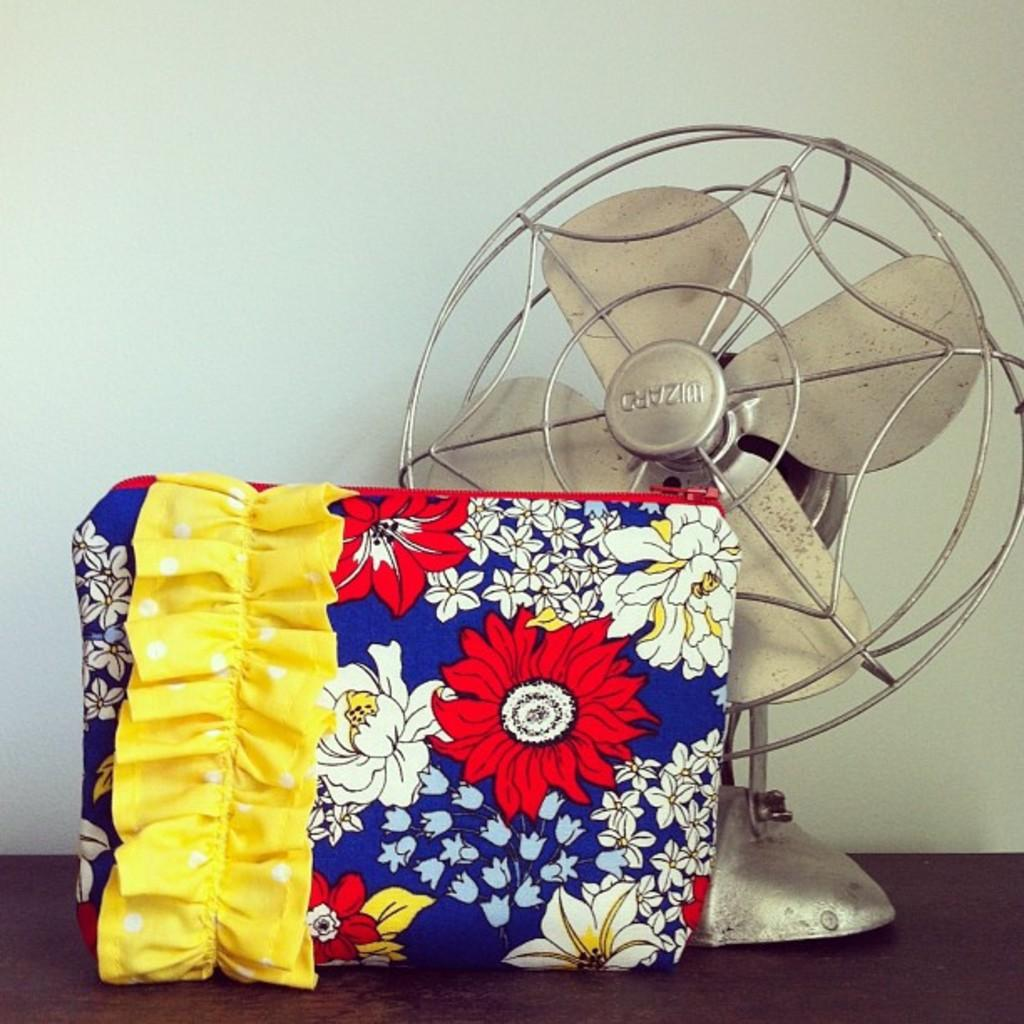What type of appliance is visible in the image? There is a table fan in the image. What else can be seen in the image besides the table fan? There is a bag in the image. How many cattle are present in the image? There are no cattle present in the image. What type of adjustment can be made to the library in the image? There is no library present in the image, so no adjustments can be made to it. 